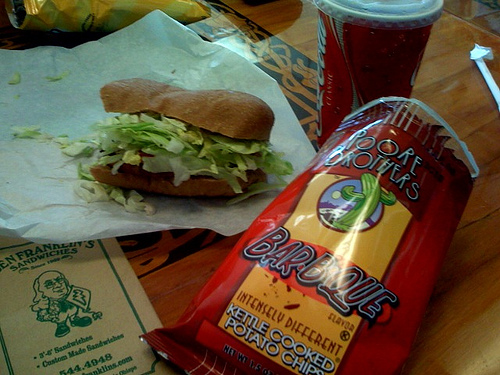Read and extract the text from this image. INTENSELY DIFFERENT KETTLE COOKED 4948 A948 Made Sandwiches SANDWICHES FRANKLIN'S POTATO BAR-BQUE 